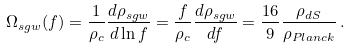<formula> <loc_0><loc_0><loc_500><loc_500>\Omega _ { s g w } ( f ) = \frac { 1 } { \rho _ { c } } \frac { d \rho _ { s g w } } { d \ln f } = \frac { f } { \rho _ { c } } \frac { d \rho _ { s g w } } { d f } = \frac { 1 6 } { 9 } \frac { \rho _ { d S } } { \rho _ { P l a n c k } } \, .</formula> 